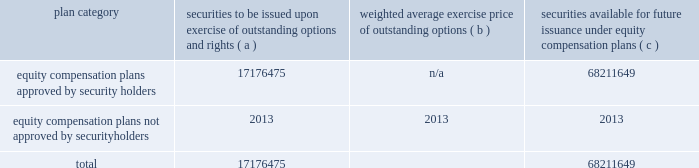The goldman sachs group , inc .
And subsidiaries item 9 .
Changes in and disagreements with accountants on accounting and financial disclosure there were no changes in or disagreements with accountants on accounting and financial disclosure during the last two years .
Item 9a .
Controls and procedures as of the end of the period covered by this report , an evaluation was carried out by goldman sachs 2019 management , with the participation of our chief executive officer and chief financial officer , of the effectiveness of our disclosure controls and procedures ( as defined in rule 13a-15 ( e ) under the exchange act ) .
Based upon that evaluation , our chief executive officer and chief financial officer concluded that these disclosure controls and procedures were effective as of the end of the period covered by this report .
In addition , no change in our internal control over financial reporting ( as defined in rule 13a-15 ( f ) under the exchange act ) occurred during the fourth quarter of our year ended december 31 , 2018 that has materially affected , or is reasonably likely to materially affect , our internal control over financial reporting .
Management 2019s report on internal control over financial reporting and the report of independent registered public accounting firm are set forth in part ii , item 8 of this form 10-k .
Item 9b .
Other information not applicable .
Part iii item 10 .
Directors , executive officers and corporate governance information relating to our executive officers is included on page 20 of this form 10-k .
Information relating to our directors , including our audit committee and audit committee financial experts and the procedures by which shareholders can recommend director nominees , and our executive officers will be in our definitive proxy statement for our 2019 annual meeting of shareholders , which will be filed within 120 days of the end of 2018 ( 2019 proxy statement ) and is incorporated in this form 10-k by reference .
Information relating to our code of business conduct and ethics , which applies to our senior financial officers , is included in 201cbusiness 2014 available information 201d in part i , item 1 of this form 10-k .
Item 11 .
Executive compensation information relating to our executive officer and director compensation and the compensation committee of the board will be in the 2019 proxy statement and is incorporated in this form 10-k by reference .
Item 12 .
Security ownership of certain beneficial owners and management and related stockholder matters information relating to security ownership of certain beneficial owners of our common stock and information relating to the security ownership of our management will be in the 2019 proxy statement and is incorporated in this form 10-k by reference .
The table below presents information as of december 31 , 2018 regarding securities to be issued pursuant to outstanding restricted stock units ( rsus ) and securities remaining available for issuance under our equity compensation plans that were in effect during 2018 .
Plan category securities to be issued exercise of outstanding options and rights ( a ) weighted average exercise price of outstanding options ( b ) securities available for future issuance under equity compensation plans ( c ) equity compensation plans approved by security holders 17176475 n/a 68211649 equity compensation plans not approved by security holders 2013 2013 2013 .
In the table above : 2030 securities to be issued upon exercise of outstanding options and rights includes 17176475 shares that may be issued pursuant to outstanding rsus .
These awards are subject to vesting and other conditions to the extent set forth in the respective award agreements , and the underlying shares will be delivered net of any required tax withholding .
As of december 31 , 2018 , there were no outstanding options .
2030 shares underlying rsus are deliverable without the payment of any consideration , and therefore these awards have not been taken into account in calculating the weighted average exercise price .
196 goldman sachs 2018 form 10-k .
What portion of the securities approved by security holders is to be issued upon exercise of outstanding options and rights? 
Computations: (17176475 / (17176475 + 68211649))
Answer: 0.20116. 